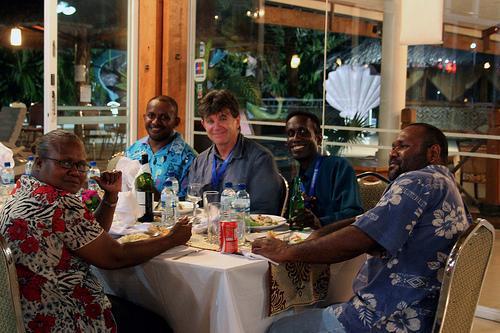How many peole wearing glasses in the restaurant?
Give a very brief answer. 1. 